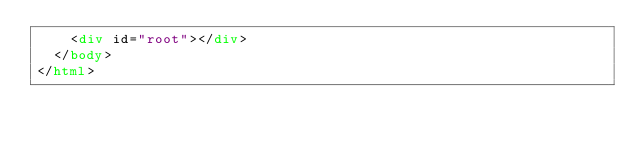<code> <loc_0><loc_0><loc_500><loc_500><_HTML_>    <div id="root"></div>
  </body>
</html>
</code> 